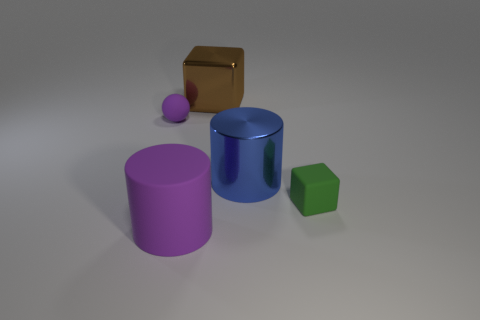Is the shape of the blue thing the same as the big brown object?
Keep it short and to the point. No. Are there any other things that are the same shape as the small green rubber object?
Provide a short and direct response. Yes. Are any green cubes visible?
Offer a very short reply. Yes. There is a green thing; is it the same shape as the rubber object behind the green object?
Ensure brevity in your answer.  No. There is a cylinder behind the large cylinder that is to the left of the blue cylinder; what is its material?
Give a very brief answer. Metal. What color is the big metallic cylinder?
Your answer should be compact. Blue. Is the color of the rubber thing right of the large purple cylinder the same as the rubber object to the left of the large purple cylinder?
Offer a very short reply. No. What size is the other object that is the same shape as the small green matte object?
Offer a terse response. Large. Is there a object of the same color as the large metal cube?
Ensure brevity in your answer.  No. What is the material of the tiny object that is the same color as the matte cylinder?
Provide a short and direct response. Rubber. 